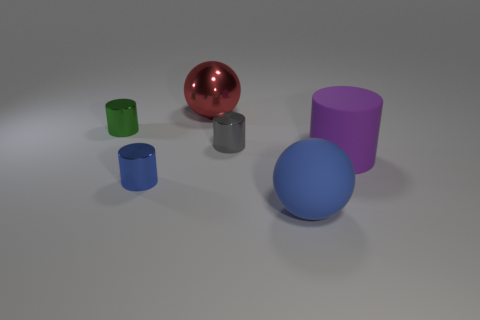The purple thing that is the same size as the red shiny thing is what shape?
Your answer should be compact. Cylinder. There is a sphere that is right of the red sphere; are there any objects that are to the left of it?
Provide a succinct answer. Yes. The big rubber object that is the same shape as the tiny gray shiny thing is what color?
Keep it short and to the point. Purple. Do the large ball that is on the right side of the gray thing and the rubber cylinder have the same color?
Your answer should be compact. No. How many objects are either things to the left of the large blue ball or tiny purple metallic things?
Your response must be concise. 4. There is a big sphere that is on the right side of the ball behind the rubber thing that is behind the blue cylinder; what is it made of?
Provide a succinct answer. Rubber. Is the number of spheres that are in front of the small green metallic thing greater than the number of small blue metallic objects right of the big red metallic sphere?
Offer a terse response. Yes. How many cylinders are small gray things or blue shiny things?
Your answer should be compact. 2. How many large rubber cylinders are behind the tiny metal object right of the sphere that is to the left of the blue matte thing?
Provide a succinct answer. 0. Are there more tiny shiny cylinders than small green shiny things?
Make the answer very short. Yes. 